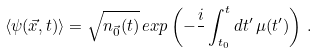Convert formula to latex. <formula><loc_0><loc_0><loc_500><loc_500>\langle \psi ( \vec { x } , t ) \rangle = \sqrt { n _ { \vec { 0 } } ( t ) } \, e x p \left ( - \frac { i } { } \int _ { t _ { 0 } } ^ { t } d t ^ { \prime } \, \mu ( t ^ { \prime } ) \right ) \, .</formula> 